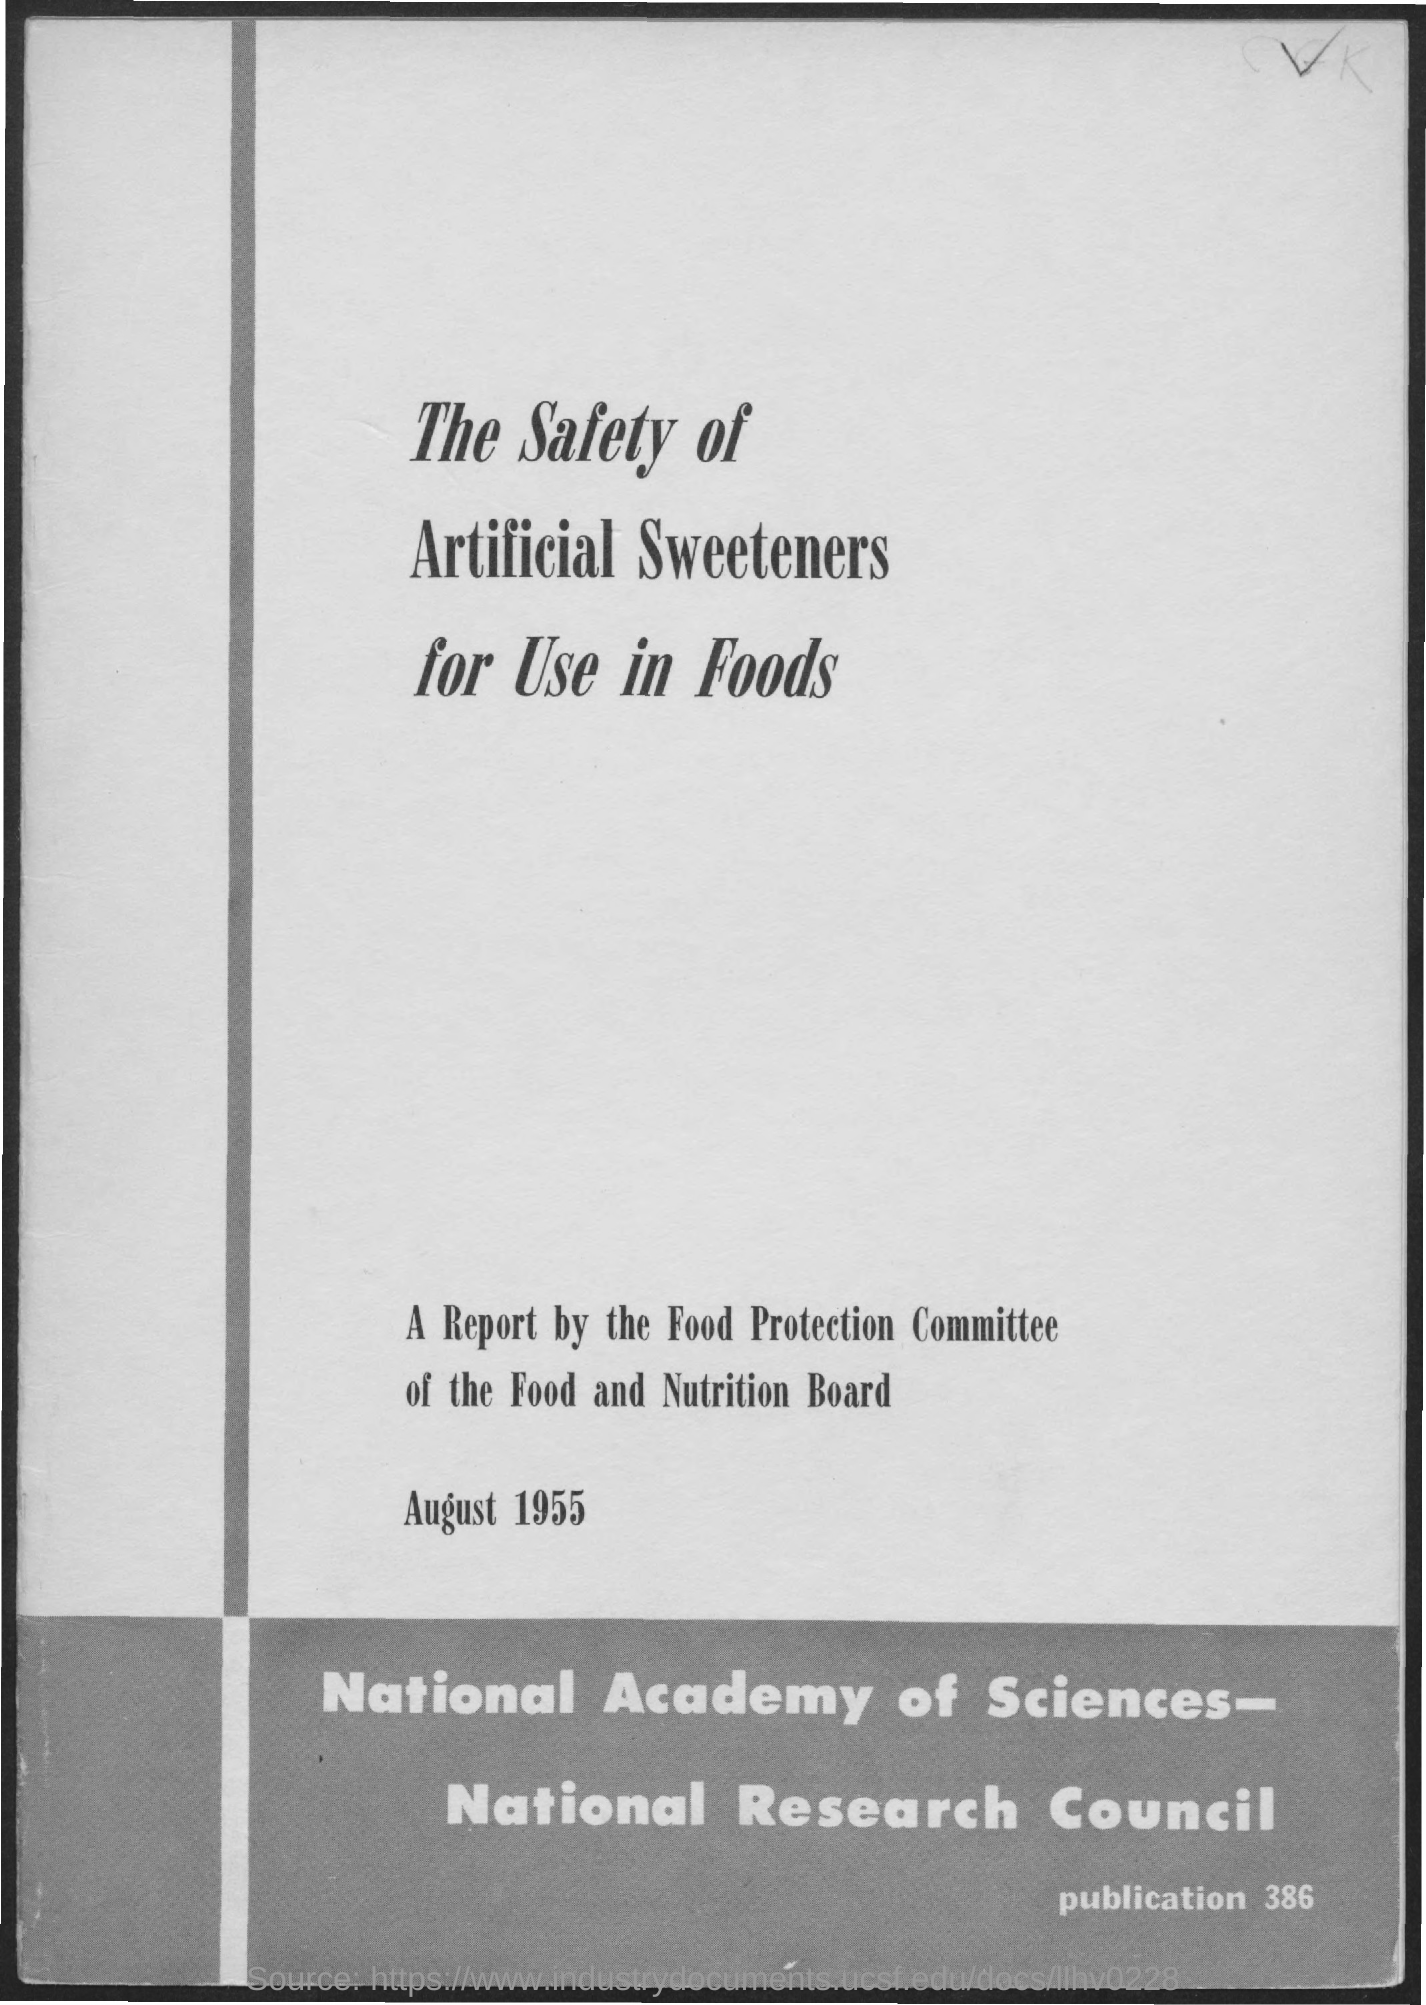What is the date on the document?
Give a very brief answer. August 1955. What is the Publication Number?
Offer a terse response. 386. 